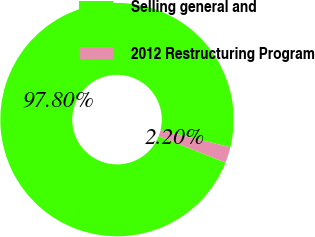Convert chart to OTSL. <chart><loc_0><loc_0><loc_500><loc_500><pie_chart><fcel>Selling general and<fcel>2012 Restructuring Program<nl><fcel>97.8%<fcel>2.2%<nl></chart> 